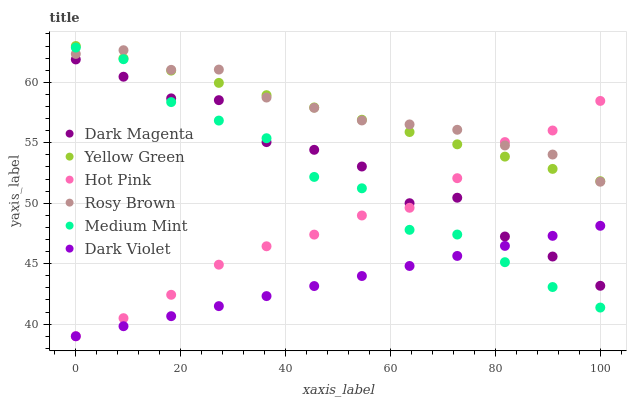Does Dark Violet have the minimum area under the curve?
Answer yes or no. Yes. Does Rosy Brown have the maximum area under the curve?
Answer yes or no. Yes. Does Hot Pink have the minimum area under the curve?
Answer yes or no. No. Does Hot Pink have the maximum area under the curve?
Answer yes or no. No. Is Yellow Green the smoothest?
Answer yes or no. Yes. Is Dark Magenta the roughest?
Answer yes or no. Yes. Is Hot Pink the smoothest?
Answer yes or no. No. Is Hot Pink the roughest?
Answer yes or no. No. Does Hot Pink have the lowest value?
Answer yes or no. Yes. Does Dark Magenta have the lowest value?
Answer yes or no. No. Does Yellow Green have the highest value?
Answer yes or no. Yes. Does Hot Pink have the highest value?
Answer yes or no. No. Is Dark Magenta less than Rosy Brown?
Answer yes or no. Yes. Is Yellow Green greater than Medium Mint?
Answer yes or no. Yes. Does Rosy Brown intersect Hot Pink?
Answer yes or no. Yes. Is Rosy Brown less than Hot Pink?
Answer yes or no. No. Is Rosy Brown greater than Hot Pink?
Answer yes or no. No. Does Dark Magenta intersect Rosy Brown?
Answer yes or no. No. 